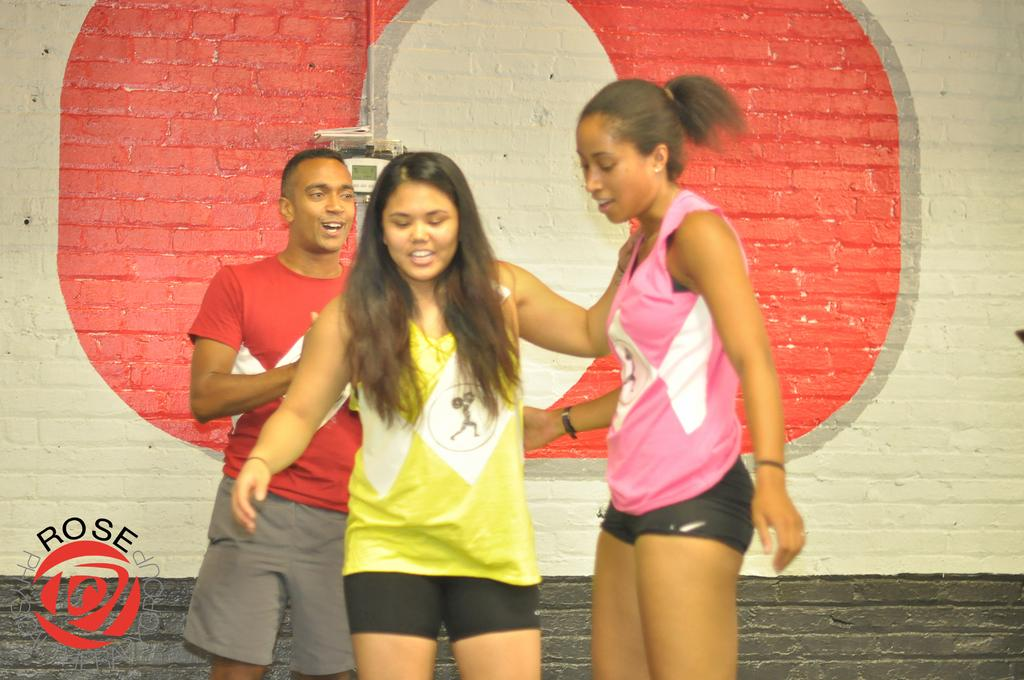How many people are present in the image? There are three persons standing in the image. What can be seen in the background of the image? There is a wall visible in the background of the image. What type of sail can be seen in the image? There is no sail present in the image. What kind of laborer is working near the river in the image? There is no laborer or river present in the image. 